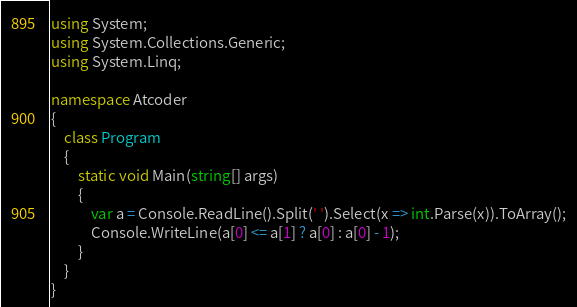Convert code to text. <code><loc_0><loc_0><loc_500><loc_500><_C#_>using System;
using System.Collections.Generic;
using System.Linq;

namespace Atcoder
{
    class Program
    {
        static void Main(string[] args)
        {
            var a = Console.ReadLine().Split(' ').Select(x => int.Parse(x)).ToArray();
            Console.WriteLine(a[0] <= a[1] ? a[0] : a[0] - 1);
        }
    }
}

</code> 